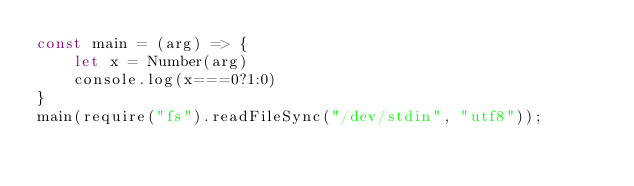<code> <loc_0><loc_0><loc_500><loc_500><_JavaScript_>const main = (arg) => {
  	let x = Number(arg)
    console.log(x===0?1:0)
}
main(require("fs").readFileSync("/dev/stdin", "utf8"));</code> 